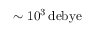<formula> <loc_0><loc_0><loc_500><loc_500>\sim 1 0 ^ { 3 } \, d e b y e</formula> 